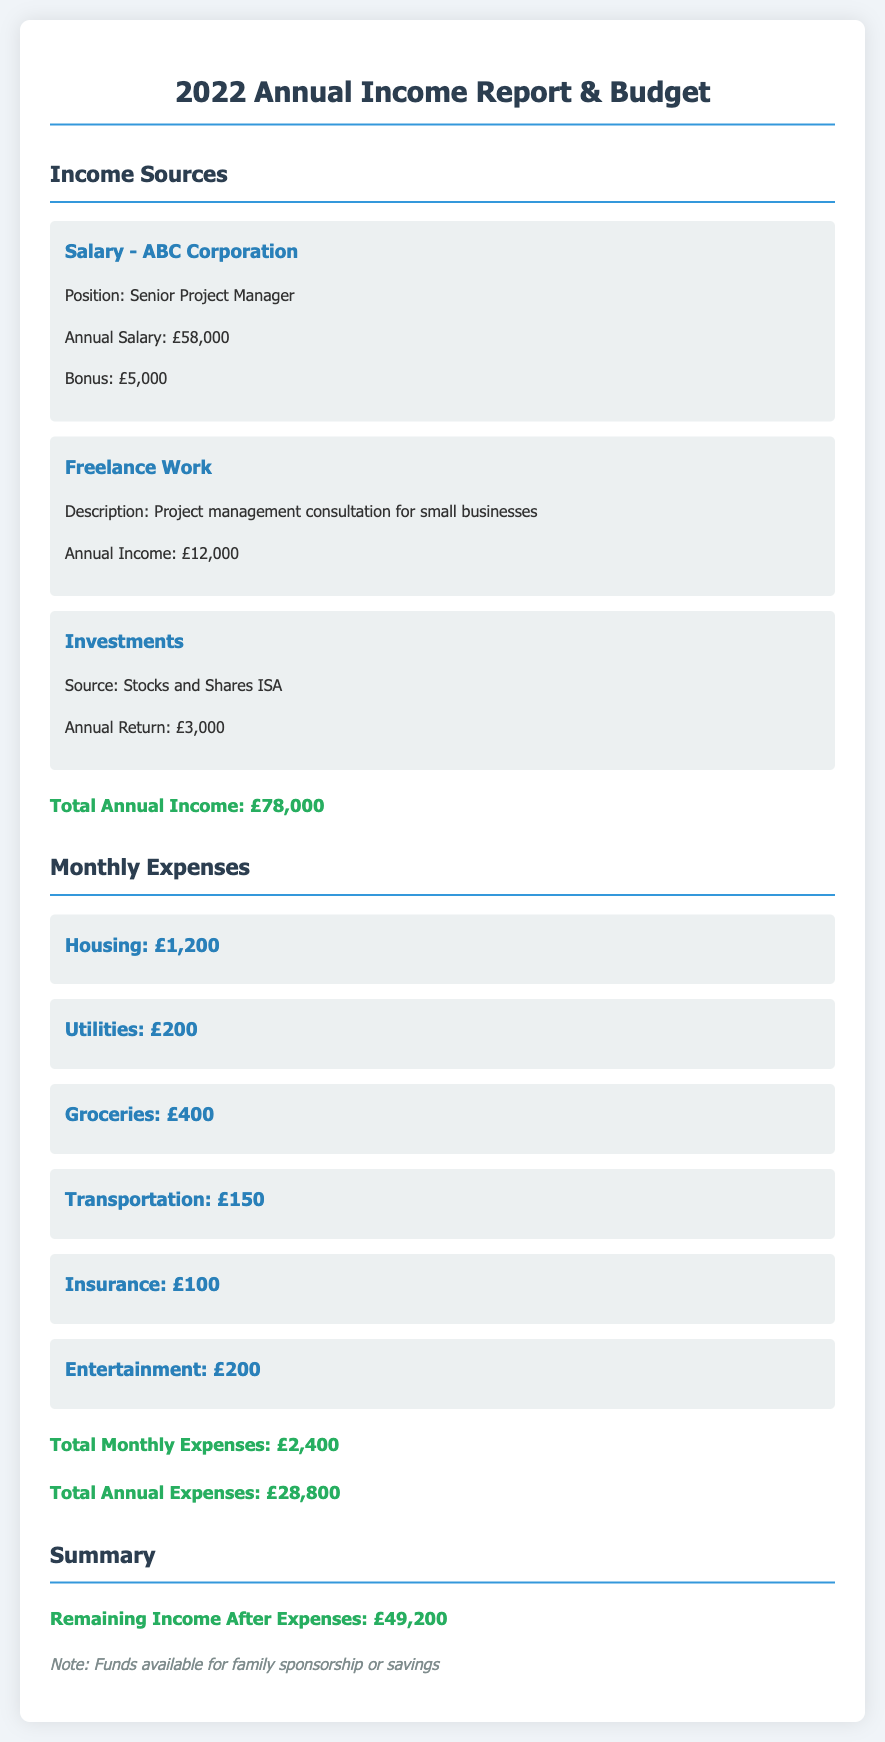What is the annual salary from ABC Corporation? The annual salary from ABC Corporation is stated explicitly in the document under income sources.
Answer: £58,000 What is the bonus amount received? The document specifies the bonus amount associated with the salary from ABC Corporation.
Answer: £5,000 What is the total annual income? The total annual income is calculated by summing up all income sources provided in the document.
Answer: £78,000 What is the monthly expense for housing? The document provides the specific amount allocated for housing as a monthly expense.
Answer: £1,200 How much is spent monthly on groceries? The document lists monthly grocery expenses as a separate item under monthly expenses.
Answer: £400 What is the total annual expense? The total annual expense is derived from the monthly expenses listed in the document multiplied by 12.
Answer: £28,800 What is the remaining income after expenses? The document outlines the remaining income by subtracting total annual expenses from total annual income.
Answer: £49,200 What is the description of the freelance work? The document includes a description of the freelance work under the income sources section.
Answer: Project management consultation for small businesses What is the annual return from investments? The document specifies the annual return for investments mentioned in the income sources.
Answer: £3,000 